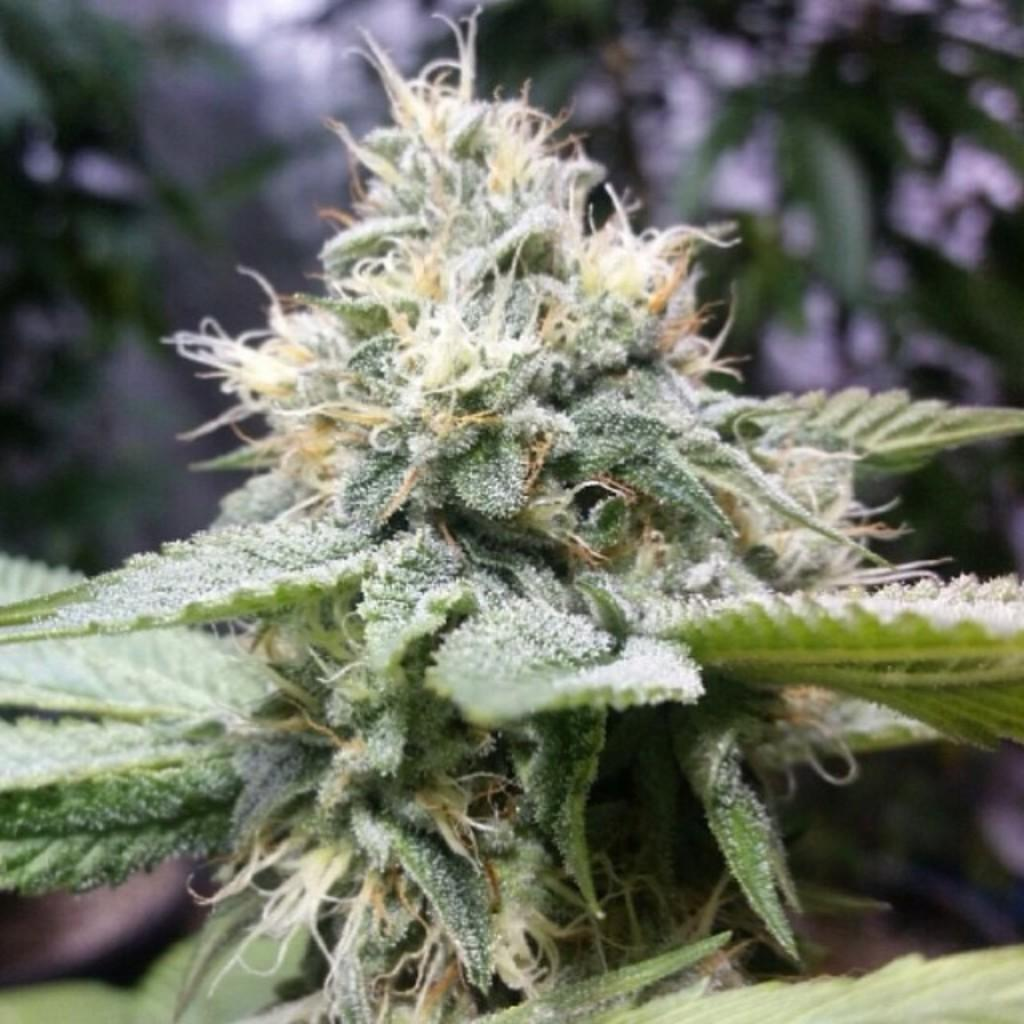What type of living organism is present in the image? There is a plant in the image. What color is the plant in the image? The plant is green. What can be seen in the background of the image? There are trees in the background of the image. What color are the trees in the image? The trees are green. What color is the sky in the image? The sky is white in color. Can you tell me how many pans are stacked on top of the tub in the image? There are no pans or tubs present in the image; it features a plant, trees, and a white sky. 